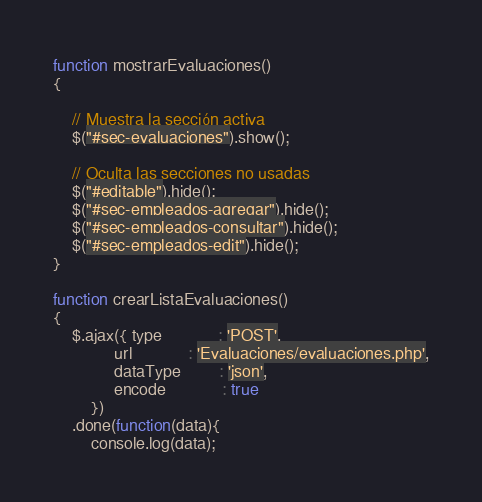<code> <loc_0><loc_0><loc_500><loc_500><_JavaScript_>function mostrarEvaluaciones()
{
	
	// Muestra la sección activa
	$("#sec-evaluaciones").show();

	// Oculta las secciones no usadas
	$("#editable").hide();
	$("#sec-empleados-agregar").hide();	
	$("#sec-empleados-consultar").hide();
	$("#sec-empleados-edit").hide();
}

function crearListaEvaluaciones()
{
	$.ajax({ type			: 'POST',
			 url	 		: 'Evaluaciones/evaluaciones.php',
			 dataType		: 'json',
			 encode			: true
		})
	.done(function(data){
		console.log(data);</code> 